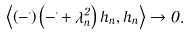<formula> <loc_0><loc_0><loc_500><loc_500>\left \langle \left ( - \Delta \right ) \left ( - \Delta + \lambda _ { n } ^ { 2 } \right ) h _ { n } , h _ { n } \right \rangle \to 0 .</formula> 